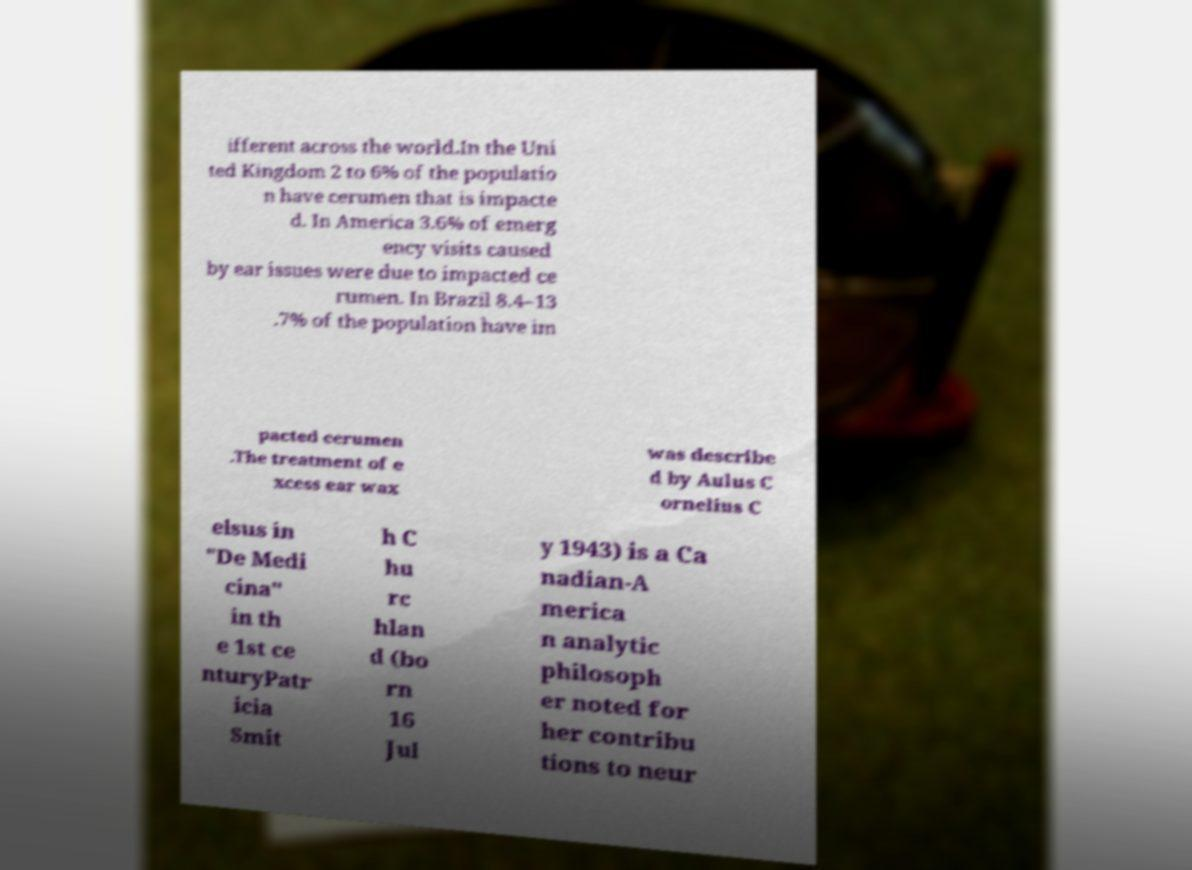Please identify and transcribe the text found in this image. ifferent across the world.In the Uni ted Kingdom 2 to 6% of the populatio n have cerumen that is impacte d. In America 3.6% of emerg ency visits caused by ear issues were due to impacted ce rumen. In Brazil 8.4–13 .7% of the population have im pacted cerumen .The treatment of e xcess ear wax was describe d by Aulus C ornelius C elsus in "De Medi cina" in th e 1st ce nturyPatr icia Smit h C hu rc hlan d (bo rn 16 Jul y 1943) is a Ca nadian-A merica n analytic philosoph er noted for her contribu tions to neur 